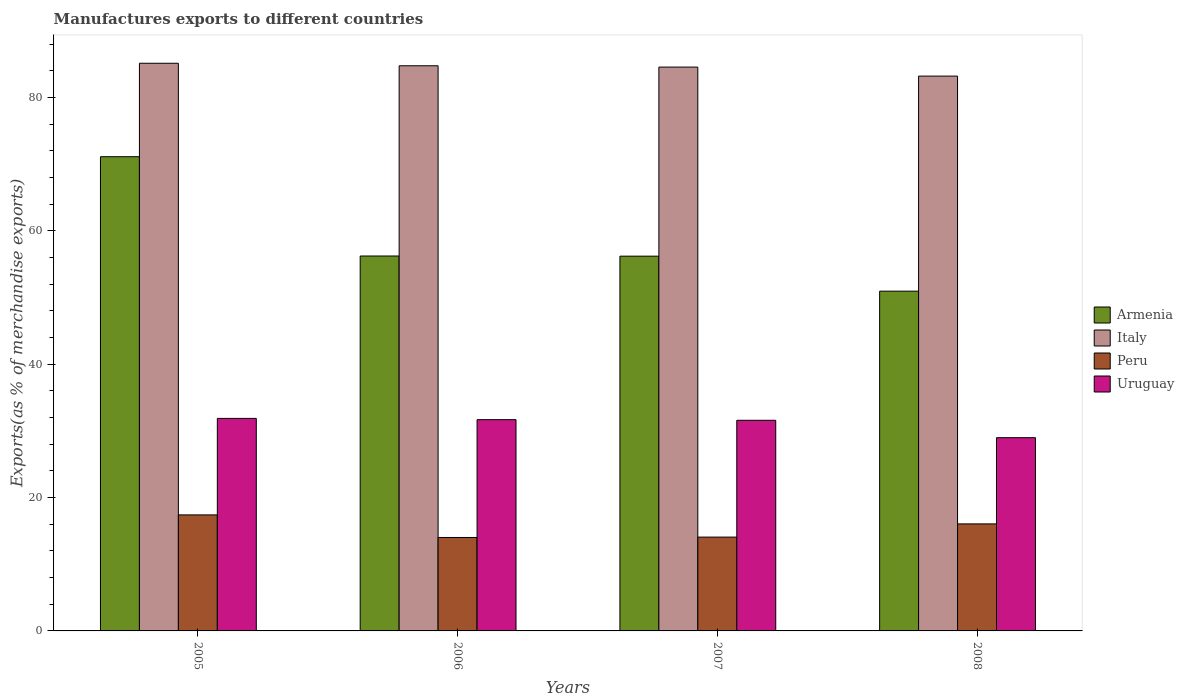How many different coloured bars are there?
Your answer should be very brief. 4. How many groups of bars are there?
Offer a terse response. 4. Are the number of bars on each tick of the X-axis equal?
Your answer should be very brief. Yes. How many bars are there on the 4th tick from the right?
Ensure brevity in your answer.  4. What is the label of the 3rd group of bars from the left?
Make the answer very short. 2007. In how many cases, is the number of bars for a given year not equal to the number of legend labels?
Offer a terse response. 0. What is the percentage of exports to different countries in Armenia in 2008?
Give a very brief answer. 50.96. Across all years, what is the maximum percentage of exports to different countries in Armenia?
Provide a short and direct response. 71.13. Across all years, what is the minimum percentage of exports to different countries in Peru?
Offer a terse response. 14.02. In which year was the percentage of exports to different countries in Peru maximum?
Offer a terse response. 2005. In which year was the percentage of exports to different countries in Uruguay minimum?
Ensure brevity in your answer.  2008. What is the total percentage of exports to different countries in Uruguay in the graph?
Your answer should be compact. 124.15. What is the difference between the percentage of exports to different countries in Armenia in 2005 and that in 2007?
Offer a very short reply. 14.92. What is the difference between the percentage of exports to different countries in Uruguay in 2007 and the percentage of exports to different countries in Peru in 2005?
Your answer should be very brief. 14.19. What is the average percentage of exports to different countries in Italy per year?
Provide a succinct answer. 84.43. In the year 2005, what is the difference between the percentage of exports to different countries in Armenia and percentage of exports to different countries in Peru?
Your answer should be compact. 53.73. What is the ratio of the percentage of exports to different countries in Uruguay in 2006 to that in 2008?
Ensure brevity in your answer.  1.09. Is the percentage of exports to different countries in Uruguay in 2006 less than that in 2008?
Make the answer very short. No. Is the difference between the percentage of exports to different countries in Armenia in 2006 and 2007 greater than the difference between the percentage of exports to different countries in Peru in 2006 and 2007?
Provide a succinct answer. Yes. What is the difference between the highest and the second highest percentage of exports to different countries in Armenia?
Keep it short and to the point. 14.9. What is the difference between the highest and the lowest percentage of exports to different countries in Peru?
Make the answer very short. 3.39. In how many years, is the percentage of exports to different countries in Italy greater than the average percentage of exports to different countries in Italy taken over all years?
Your response must be concise. 3. What does the 3rd bar from the right in 2008 represents?
Offer a terse response. Italy. Is it the case that in every year, the sum of the percentage of exports to different countries in Italy and percentage of exports to different countries in Peru is greater than the percentage of exports to different countries in Uruguay?
Your answer should be compact. Yes. Does the graph contain any zero values?
Your answer should be very brief. No. Where does the legend appear in the graph?
Offer a very short reply. Center right. How many legend labels are there?
Ensure brevity in your answer.  4. How are the legend labels stacked?
Your response must be concise. Vertical. What is the title of the graph?
Your answer should be very brief. Manufactures exports to different countries. Does "Bahamas" appear as one of the legend labels in the graph?
Ensure brevity in your answer.  No. What is the label or title of the X-axis?
Ensure brevity in your answer.  Years. What is the label or title of the Y-axis?
Provide a short and direct response. Exports(as % of merchandise exports). What is the Exports(as % of merchandise exports) of Armenia in 2005?
Ensure brevity in your answer.  71.13. What is the Exports(as % of merchandise exports) in Italy in 2005?
Keep it short and to the point. 85.15. What is the Exports(as % of merchandise exports) in Peru in 2005?
Offer a terse response. 17.4. What is the Exports(as % of merchandise exports) in Uruguay in 2005?
Provide a short and direct response. 31.88. What is the Exports(as % of merchandise exports) of Armenia in 2006?
Ensure brevity in your answer.  56.24. What is the Exports(as % of merchandise exports) in Italy in 2006?
Your answer should be compact. 84.77. What is the Exports(as % of merchandise exports) of Peru in 2006?
Offer a terse response. 14.02. What is the Exports(as % of merchandise exports) in Uruguay in 2006?
Provide a short and direct response. 31.69. What is the Exports(as % of merchandise exports) in Armenia in 2007?
Make the answer very short. 56.21. What is the Exports(as % of merchandise exports) of Italy in 2007?
Provide a short and direct response. 84.58. What is the Exports(as % of merchandise exports) of Peru in 2007?
Ensure brevity in your answer.  14.07. What is the Exports(as % of merchandise exports) in Uruguay in 2007?
Give a very brief answer. 31.6. What is the Exports(as % of merchandise exports) in Armenia in 2008?
Ensure brevity in your answer.  50.96. What is the Exports(as % of merchandise exports) of Italy in 2008?
Your answer should be compact. 83.22. What is the Exports(as % of merchandise exports) in Peru in 2008?
Make the answer very short. 16.05. What is the Exports(as % of merchandise exports) of Uruguay in 2008?
Your response must be concise. 28.99. Across all years, what is the maximum Exports(as % of merchandise exports) in Armenia?
Your answer should be compact. 71.13. Across all years, what is the maximum Exports(as % of merchandise exports) of Italy?
Your answer should be compact. 85.15. Across all years, what is the maximum Exports(as % of merchandise exports) in Peru?
Offer a terse response. 17.4. Across all years, what is the maximum Exports(as % of merchandise exports) of Uruguay?
Provide a short and direct response. 31.88. Across all years, what is the minimum Exports(as % of merchandise exports) in Armenia?
Your answer should be compact. 50.96. Across all years, what is the minimum Exports(as % of merchandise exports) of Italy?
Keep it short and to the point. 83.22. Across all years, what is the minimum Exports(as % of merchandise exports) of Peru?
Your answer should be compact. 14.02. Across all years, what is the minimum Exports(as % of merchandise exports) of Uruguay?
Give a very brief answer. 28.99. What is the total Exports(as % of merchandise exports) of Armenia in the graph?
Keep it short and to the point. 234.55. What is the total Exports(as % of merchandise exports) in Italy in the graph?
Your answer should be very brief. 337.72. What is the total Exports(as % of merchandise exports) in Peru in the graph?
Your response must be concise. 61.54. What is the total Exports(as % of merchandise exports) in Uruguay in the graph?
Keep it short and to the point. 124.15. What is the difference between the Exports(as % of merchandise exports) of Armenia in 2005 and that in 2006?
Your response must be concise. 14.9. What is the difference between the Exports(as % of merchandise exports) of Italy in 2005 and that in 2006?
Make the answer very short. 0.38. What is the difference between the Exports(as % of merchandise exports) of Peru in 2005 and that in 2006?
Provide a succinct answer. 3.39. What is the difference between the Exports(as % of merchandise exports) of Uruguay in 2005 and that in 2006?
Your answer should be compact. 0.19. What is the difference between the Exports(as % of merchandise exports) of Armenia in 2005 and that in 2007?
Offer a very short reply. 14.92. What is the difference between the Exports(as % of merchandise exports) of Italy in 2005 and that in 2007?
Your answer should be compact. 0.57. What is the difference between the Exports(as % of merchandise exports) of Peru in 2005 and that in 2007?
Your answer should be compact. 3.33. What is the difference between the Exports(as % of merchandise exports) in Uruguay in 2005 and that in 2007?
Provide a short and direct response. 0.28. What is the difference between the Exports(as % of merchandise exports) of Armenia in 2005 and that in 2008?
Your answer should be very brief. 20.17. What is the difference between the Exports(as % of merchandise exports) in Italy in 2005 and that in 2008?
Keep it short and to the point. 1.93. What is the difference between the Exports(as % of merchandise exports) of Peru in 2005 and that in 2008?
Ensure brevity in your answer.  1.35. What is the difference between the Exports(as % of merchandise exports) of Uruguay in 2005 and that in 2008?
Offer a very short reply. 2.89. What is the difference between the Exports(as % of merchandise exports) in Armenia in 2006 and that in 2007?
Your response must be concise. 0.02. What is the difference between the Exports(as % of merchandise exports) in Italy in 2006 and that in 2007?
Ensure brevity in your answer.  0.2. What is the difference between the Exports(as % of merchandise exports) of Peru in 2006 and that in 2007?
Your answer should be compact. -0.06. What is the difference between the Exports(as % of merchandise exports) of Uruguay in 2006 and that in 2007?
Provide a succinct answer. 0.09. What is the difference between the Exports(as % of merchandise exports) of Armenia in 2006 and that in 2008?
Your answer should be very brief. 5.27. What is the difference between the Exports(as % of merchandise exports) of Italy in 2006 and that in 2008?
Give a very brief answer. 1.55. What is the difference between the Exports(as % of merchandise exports) in Peru in 2006 and that in 2008?
Provide a succinct answer. -2.04. What is the difference between the Exports(as % of merchandise exports) in Uruguay in 2006 and that in 2008?
Provide a succinct answer. 2.7. What is the difference between the Exports(as % of merchandise exports) of Armenia in 2007 and that in 2008?
Your answer should be very brief. 5.25. What is the difference between the Exports(as % of merchandise exports) of Italy in 2007 and that in 2008?
Your answer should be very brief. 1.35. What is the difference between the Exports(as % of merchandise exports) of Peru in 2007 and that in 2008?
Give a very brief answer. -1.98. What is the difference between the Exports(as % of merchandise exports) in Uruguay in 2007 and that in 2008?
Provide a short and direct response. 2.61. What is the difference between the Exports(as % of merchandise exports) in Armenia in 2005 and the Exports(as % of merchandise exports) in Italy in 2006?
Offer a terse response. -13.64. What is the difference between the Exports(as % of merchandise exports) in Armenia in 2005 and the Exports(as % of merchandise exports) in Peru in 2006?
Your answer should be very brief. 57.12. What is the difference between the Exports(as % of merchandise exports) in Armenia in 2005 and the Exports(as % of merchandise exports) in Uruguay in 2006?
Provide a succinct answer. 39.44. What is the difference between the Exports(as % of merchandise exports) in Italy in 2005 and the Exports(as % of merchandise exports) in Peru in 2006?
Make the answer very short. 71.13. What is the difference between the Exports(as % of merchandise exports) in Italy in 2005 and the Exports(as % of merchandise exports) in Uruguay in 2006?
Your answer should be very brief. 53.46. What is the difference between the Exports(as % of merchandise exports) of Peru in 2005 and the Exports(as % of merchandise exports) of Uruguay in 2006?
Your response must be concise. -14.29. What is the difference between the Exports(as % of merchandise exports) in Armenia in 2005 and the Exports(as % of merchandise exports) in Italy in 2007?
Offer a very short reply. -13.44. What is the difference between the Exports(as % of merchandise exports) of Armenia in 2005 and the Exports(as % of merchandise exports) of Peru in 2007?
Make the answer very short. 57.06. What is the difference between the Exports(as % of merchandise exports) in Armenia in 2005 and the Exports(as % of merchandise exports) in Uruguay in 2007?
Ensure brevity in your answer.  39.54. What is the difference between the Exports(as % of merchandise exports) in Italy in 2005 and the Exports(as % of merchandise exports) in Peru in 2007?
Your response must be concise. 71.08. What is the difference between the Exports(as % of merchandise exports) of Italy in 2005 and the Exports(as % of merchandise exports) of Uruguay in 2007?
Your answer should be compact. 53.55. What is the difference between the Exports(as % of merchandise exports) of Peru in 2005 and the Exports(as % of merchandise exports) of Uruguay in 2007?
Your answer should be compact. -14.19. What is the difference between the Exports(as % of merchandise exports) in Armenia in 2005 and the Exports(as % of merchandise exports) in Italy in 2008?
Your answer should be compact. -12.09. What is the difference between the Exports(as % of merchandise exports) of Armenia in 2005 and the Exports(as % of merchandise exports) of Peru in 2008?
Provide a succinct answer. 55.08. What is the difference between the Exports(as % of merchandise exports) in Armenia in 2005 and the Exports(as % of merchandise exports) in Uruguay in 2008?
Give a very brief answer. 42.15. What is the difference between the Exports(as % of merchandise exports) of Italy in 2005 and the Exports(as % of merchandise exports) of Peru in 2008?
Offer a very short reply. 69.1. What is the difference between the Exports(as % of merchandise exports) in Italy in 2005 and the Exports(as % of merchandise exports) in Uruguay in 2008?
Your answer should be compact. 56.16. What is the difference between the Exports(as % of merchandise exports) of Peru in 2005 and the Exports(as % of merchandise exports) of Uruguay in 2008?
Make the answer very short. -11.58. What is the difference between the Exports(as % of merchandise exports) in Armenia in 2006 and the Exports(as % of merchandise exports) in Italy in 2007?
Ensure brevity in your answer.  -28.34. What is the difference between the Exports(as % of merchandise exports) of Armenia in 2006 and the Exports(as % of merchandise exports) of Peru in 2007?
Make the answer very short. 42.16. What is the difference between the Exports(as % of merchandise exports) of Armenia in 2006 and the Exports(as % of merchandise exports) of Uruguay in 2007?
Make the answer very short. 24.64. What is the difference between the Exports(as % of merchandise exports) of Italy in 2006 and the Exports(as % of merchandise exports) of Peru in 2007?
Provide a succinct answer. 70.7. What is the difference between the Exports(as % of merchandise exports) of Italy in 2006 and the Exports(as % of merchandise exports) of Uruguay in 2007?
Your answer should be compact. 53.18. What is the difference between the Exports(as % of merchandise exports) of Peru in 2006 and the Exports(as % of merchandise exports) of Uruguay in 2007?
Your answer should be compact. -17.58. What is the difference between the Exports(as % of merchandise exports) of Armenia in 2006 and the Exports(as % of merchandise exports) of Italy in 2008?
Keep it short and to the point. -26.99. What is the difference between the Exports(as % of merchandise exports) of Armenia in 2006 and the Exports(as % of merchandise exports) of Peru in 2008?
Ensure brevity in your answer.  40.18. What is the difference between the Exports(as % of merchandise exports) of Armenia in 2006 and the Exports(as % of merchandise exports) of Uruguay in 2008?
Offer a terse response. 27.25. What is the difference between the Exports(as % of merchandise exports) in Italy in 2006 and the Exports(as % of merchandise exports) in Peru in 2008?
Your response must be concise. 68.72. What is the difference between the Exports(as % of merchandise exports) in Italy in 2006 and the Exports(as % of merchandise exports) in Uruguay in 2008?
Your answer should be compact. 55.79. What is the difference between the Exports(as % of merchandise exports) of Peru in 2006 and the Exports(as % of merchandise exports) of Uruguay in 2008?
Your answer should be compact. -14.97. What is the difference between the Exports(as % of merchandise exports) of Armenia in 2007 and the Exports(as % of merchandise exports) of Italy in 2008?
Make the answer very short. -27.01. What is the difference between the Exports(as % of merchandise exports) of Armenia in 2007 and the Exports(as % of merchandise exports) of Peru in 2008?
Your answer should be very brief. 40.16. What is the difference between the Exports(as % of merchandise exports) of Armenia in 2007 and the Exports(as % of merchandise exports) of Uruguay in 2008?
Your answer should be compact. 27.23. What is the difference between the Exports(as % of merchandise exports) in Italy in 2007 and the Exports(as % of merchandise exports) in Peru in 2008?
Your answer should be very brief. 68.52. What is the difference between the Exports(as % of merchandise exports) of Italy in 2007 and the Exports(as % of merchandise exports) of Uruguay in 2008?
Provide a short and direct response. 55.59. What is the difference between the Exports(as % of merchandise exports) in Peru in 2007 and the Exports(as % of merchandise exports) in Uruguay in 2008?
Your answer should be very brief. -14.91. What is the average Exports(as % of merchandise exports) of Armenia per year?
Give a very brief answer. 58.64. What is the average Exports(as % of merchandise exports) of Italy per year?
Your answer should be very brief. 84.43. What is the average Exports(as % of merchandise exports) of Peru per year?
Keep it short and to the point. 15.39. What is the average Exports(as % of merchandise exports) of Uruguay per year?
Give a very brief answer. 31.04. In the year 2005, what is the difference between the Exports(as % of merchandise exports) of Armenia and Exports(as % of merchandise exports) of Italy?
Provide a succinct answer. -14.02. In the year 2005, what is the difference between the Exports(as % of merchandise exports) of Armenia and Exports(as % of merchandise exports) of Peru?
Your answer should be compact. 53.73. In the year 2005, what is the difference between the Exports(as % of merchandise exports) of Armenia and Exports(as % of merchandise exports) of Uruguay?
Your response must be concise. 39.26. In the year 2005, what is the difference between the Exports(as % of merchandise exports) of Italy and Exports(as % of merchandise exports) of Peru?
Your answer should be very brief. 67.75. In the year 2005, what is the difference between the Exports(as % of merchandise exports) in Italy and Exports(as % of merchandise exports) in Uruguay?
Provide a succinct answer. 53.27. In the year 2005, what is the difference between the Exports(as % of merchandise exports) in Peru and Exports(as % of merchandise exports) in Uruguay?
Provide a succinct answer. -14.47. In the year 2006, what is the difference between the Exports(as % of merchandise exports) of Armenia and Exports(as % of merchandise exports) of Italy?
Offer a very short reply. -28.54. In the year 2006, what is the difference between the Exports(as % of merchandise exports) in Armenia and Exports(as % of merchandise exports) in Peru?
Offer a very short reply. 42.22. In the year 2006, what is the difference between the Exports(as % of merchandise exports) in Armenia and Exports(as % of merchandise exports) in Uruguay?
Provide a short and direct response. 24.55. In the year 2006, what is the difference between the Exports(as % of merchandise exports) in Italy and Exports(as % of merchandise exports) in Peru?
Your answer should be compact. 70.76. In the year 2006, what is the difference between the Exports(as % of merchandise exports) of Italy and Exports(as % of merchandise exports) of Uruguay?
Give a very brief answer. 53.08. In the year 2006, what is the difference between the Exports(as % of merchandise exports) of Peru and Exports(as % of merchandise exports) of Uruguay?
Offer a very short reply. -17.67. In the year 2007, what is the difference between the Exports(as % of merchandise exports) in Armenia and Exports(as % of merchandise exports) in Italy?
Offer a terse response. -28.36. In the year 2007, what is the difference between the Exports(as % of merchandise exports) in Armenia and Exports(as % of merchandise exports) in Peru?
Offer a very short reply. 42.14. In the year 2007, what is the difference between the Exports(as % of merchandise exports) of Armenia and Exports(as % of merchandise exports) of Uruguay?
Your answer should be compact. 24.62. In the year 2007, what is the difference between the Exports(as % of merchandise exports) of Italy and Exports(as % of merchandise exports) of Peru?
Your answer should be very brief. 70.5. In the year 2007, what is the difference between the Exports(as % of merchandise exports) of Italy and Exports(as % of merchandise exports) of Uruguay?
Your answer should be very brief. 52.98. In the year 2007, what is the difference between the Exports(as % of merchandise exports) in Peru and Exports(as % of merchandise exports) in Uruguay?
Provide a succinct answer. -17.52. In the year 2008, what is the difference between the Exports(as % of merchandise exports) in Armenia and Exports(as % of merchandise exports) in Italy?
Give a very brief answer. -32.26. In the year 2008, what is the difference between the Exports(as % of merchandise exports) in Armenia and Exports(as % of merchandise exports) in Peru?
Make the answer very short. 34.91. In the year 2008, what is the difference between the Exports(as % of merchandise exports) in Armenia and Exports(as % of merchandise exports) in Uruguay?
Your answer should be very brief. 21.98. In the year 2008, what is the difference between the Exports(as % of merchandise exports) of Italy and Exports(as % of merchandise exports) of Peru?
Provide a succinct answer. 67.17. In the year 2008, what is the difference between the Exports(as % of merchandise exports) in Italy and Exports(as % of merchandise exports) in Uruguay?
Ensure brevity in your answer.  54.24. In the year 2008, what is the difference between the Exports(as % of merchandise exports) of Peru and Exports(as % of merchandise exports) of Uruguay?
Offer a terse response. -12.93. What is the ratio of the Exports(as % of merchandise exports) in Armenia in 2005 to that in 2006?
Provide a succinct answer. 1.26. What is the ratio of the Exports(as % of merchandise exports) of Italy in 2005 to that in 2006?
Offer a very short reply. 1. What is the ratio of the Exports(as % of merchandise exports) in Peru in 2005 to that in 2006?
Ensure brevity in your answer.  1.24. What is the ratio of the Exports(as % of merchandise exports) in Armenia in 2005 to that in 2007?
Provide a short and direct response. 1.27. What is the ratio of the Exports(as % of merchandise exports) in Italy in 2005 to that in 2007?
Your answer should be compact. 1.01. What is the ratio of the Exports(as % of merchandise exports) in Peru in 2005 to that in 2007?
Provide a succinct answer. 1.24. What is the ratio of the Exports(as % of merchandise exports) in Uruguay in 2005 to that in 2007?
Offer a terse response. 1.01. What is the ratio of the Exports(as % of merchandise exports) in Armenia in 2005 to that in 2008?
Make the answer very short. 1.4. What is the ratio of the Exports(as % of merchandise exports) in Italy in 2005 to that in 2008?
Keep it short and to the point. 1.02. What is the ratio of the Exports(as % of merchandise exports) in Peru in 2005 to that in 2008?
Offer a terse response. 1.08. What is the ratio of the Exports(as % of merchandise exports) of Uruguay in 2005 to that in 2008?
Offer a terse response. 1.1. What is the ratio of the Exports(as % of merchandise exports) in Armenia in 2006 to that in 2007?
Your response must be concise. 1. What is the ratio of the Exports(as % of merchandise exports) in Italy in 2006 to that in 2007?
Your answer should be compact. 1. What is the ratio of the Exports(as % of merchandise exports) of Peru in 2006 to that in 2007?
Keep it short and to the point. 1. What is the ratio of the Exports(as % of merchandise exports) in Armenia in 2006 to that in 2008?
Provide a short and direct response. 1.1. What is the ratio of the Exports(as % of merchandise exports) of Italy in 2006 to that in 2008?
Keep it short and to the point. 1.02. What is the ratio of the Exports(as % of merchandise exports) in Peru in 2006 to that in 2008?
Your answer should be very brief. 0.87. What is the ratio of the Exports(as % of merchandise exports) of Uruguay in 2006 to that in 2008?
Give a very brief answer. 1.09. What is the ratio of the Exports(as % of merchandise exports) of Armenia in 2007 to that in 2008?
Your answer should be very brief. 1.1. What is the ratio of the Exports(as % of merchandise exports) of Italy in 2007 to that in 2008?
Make the answer very short. 1.02. What is the ratio of the Exports(as % of merchandise exports) in Peru in 2007 to that in 2008?
Keep it short and to the point. 0.88. What is the ratio of the Exports(as % of merchandise exports) in Uruguay in 2007 to that in 2008?
Offer a very short reply. 1.09. What is the difference between the highest and the second highest Exports(as % of merchandise exports) in Armenia?
Give a very brief answer. 14.9. What is the difference between the highest and the second highest Exports(as % of merchandise exports) in Italy?
Offer a very short reply. 0.38. What is the difference between the highest and the second highest Exports(as % of merchandise exports) in Peru?
Provide a succinct answer. 1.35. What is the difference between the highest and the second highest Exports(as % of merchandise exports) of Uruguay?
Provide a short and direct response. 0.19. What is the difference between the highest and the lowest Exports(as % of merchandise exports) of Armenia?
Your response must be concise. 20.17. What is the difference between the highest and the lowest Exports(as % of merchandise exports) in Italy?
Provide a succinct answer. 1.93. What is the difference between the highest and the lowest Exports(as % of merchandise exports) of Peru?
Provide a short and direct response. 3.39. What is the difference between the highest and the lowest Exports(as % of merchandise exports) in Uruguay?
Your response must be concise. 2.89. 